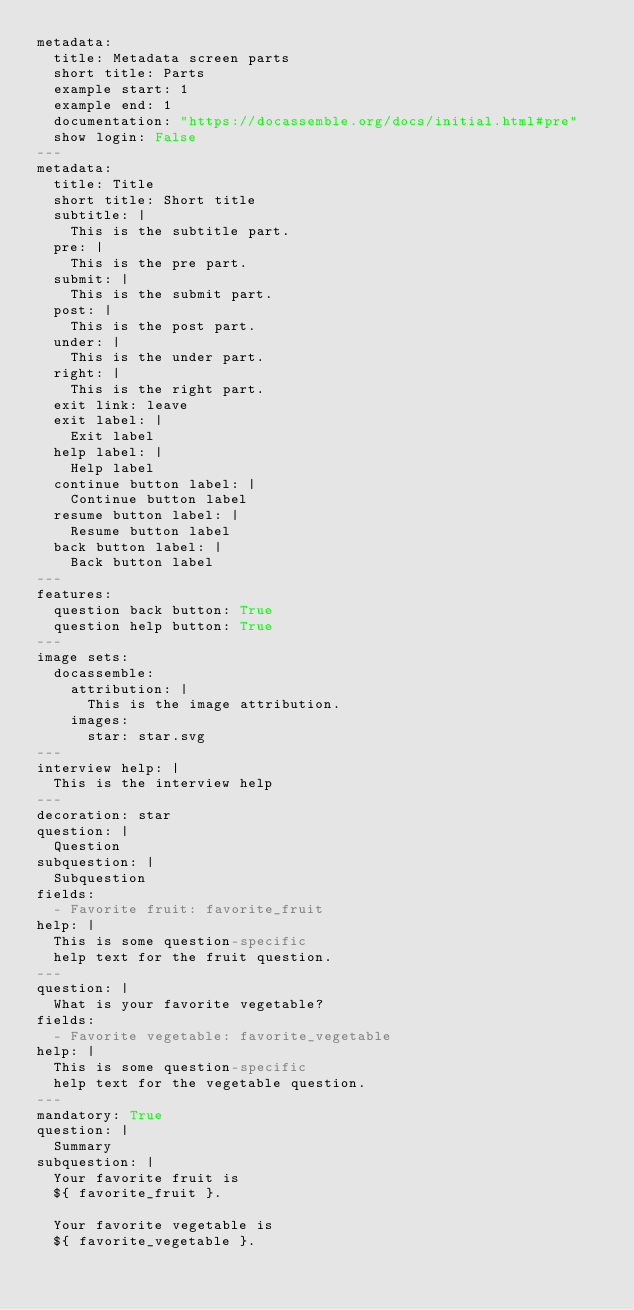Convert code to text. <code><loc_0><loc_0><loc_500><loc_500><_YAML_>metadata:
  title: Metadata screen parts
  short title: Parts
  example start: 1
  example end: 1
  documentation: "https://docassemble.org/docs/initial.html#pre"
  show login: False
---
metadata:
  title: Title
  short title: Short title
  subtitle: |
    This is the subtitle part.
  pre: |
    This is the pre part.
  submit: |
    This is the submit part.
  post: |
    This is the post part.
  under: |
    This is the under part.
  right: |
    This is the right part.
  exit link: leave
  exit label: |
    Exit label
  help label: |
    Help label
  continue button label: |
    Continue button label
  resume button label: |
    Resume button label
  back button label: |
    Back button label
---
features:
  question back button: True
  question help button: True
---
image sets:
  docassemble:
    attribution: |
      This is the image attribution.
    images:
      star: star.svg
---
interview help: |
  This is the interview help
---
decoration: star
question: |
  Question
subquestion: |
  Subquestion
fields:
  - Favorite fruit: favorite_fruit
help: |
  This is some question-specific
  help text for the fruit question.
---
question: |
  What is your favorite vegetable?
fields:
  - Favorite vegetable: favorite_vegetable
help: |
  This is some question-specific
  help text for the vegetable question.
---
mandatory: True
question: |
  Summary
subquestion: |
  Your favorite fruit is
  ${ favorite_fruit }.
  
  Your favorite vegetable is
  ${ favorite_vegetable }.

  
</code> 